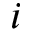<formula> <loc_0><loc_0><loc_500><loc_500>i</formula> 